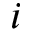<formula> <loc_0><loc_0><loc_500><loc_500>i</formula> 